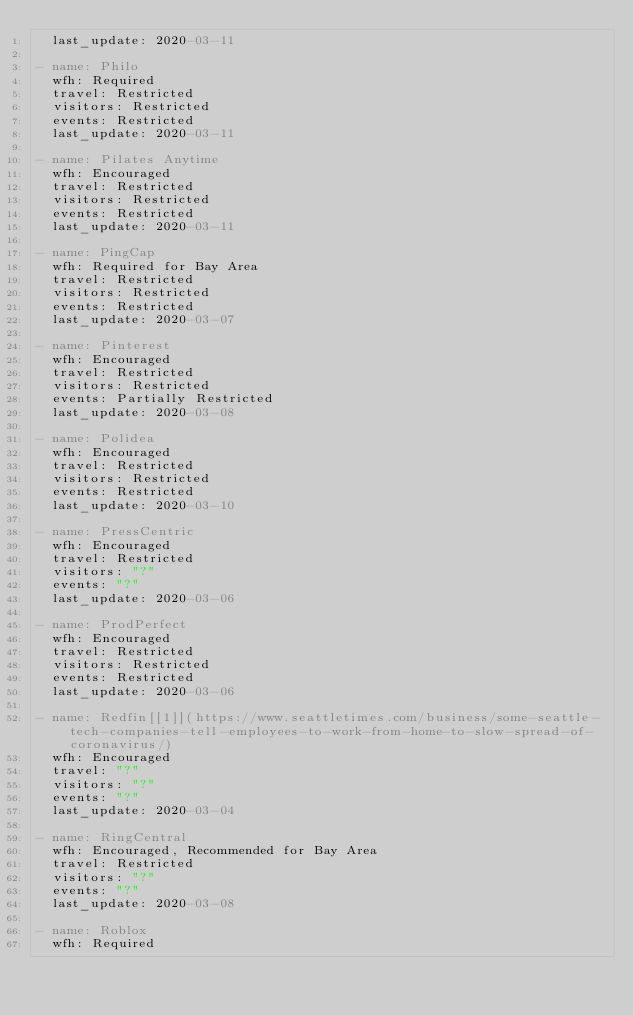<code> <loc_0><loc_0><loc_500><loc_500><_YAML_>  last_update: 2020-03-11

- name: Philo
  wfh: Required
  travel: Restricted
  visitors: Restricted
  events: Restricted
  last_update: 2020-03-11

- name: Pilates Anytime
  wfh: Encouraged
  travel: Restricted
  visitors: Restricted
  events: Restricted
  last_update: 2020-03-11

- name: PingCap
  wfh: Required for Bay Area
  travel: Restricted
  visitors: Restricted
  events: Restricted
  last_update: 2020-03-07

- name: Pinterest
  wfh: Encouraged
  travel: Restricted
  visitors: Restricted
  events: Partially Restricted
  last_update: 2020-03-08

- name: Polidea
  wfh: Encouraged
  travel: Restricted
  visitors: Restricted
  events: Restricted
  last_update: 2020-03-10

- name: PressCentric
  wfh: Encouraged
  travel: Restricted
  visitors: "?"
  events: "?"
  last_update: 2020-03-06

- name: ProdPerfect
  wfh: Encouraged
  travel: Restricted
  visitors: Restricted
  events: Restricted
  last_update: 2020-03-06

- name: Redfin[[1]](https://www.seattletimes.com/business/some-seattle-tech-companies-tell-employees-to-work-from-home-to-slow-spread-of-coronavirus/)
  wfh: Encouraged
  travel: "?"
  visitors: "?"
  events: "?"
  last_update: 2020-03-04

- name: RingCentral
  wfh: Encouraged, Recommended for Bay Area
  travel: Restricted
  visitors: "?"
  events: "?"
  last_update: 2020-03-08

- name: Roblox
  wfh: Required</code> 